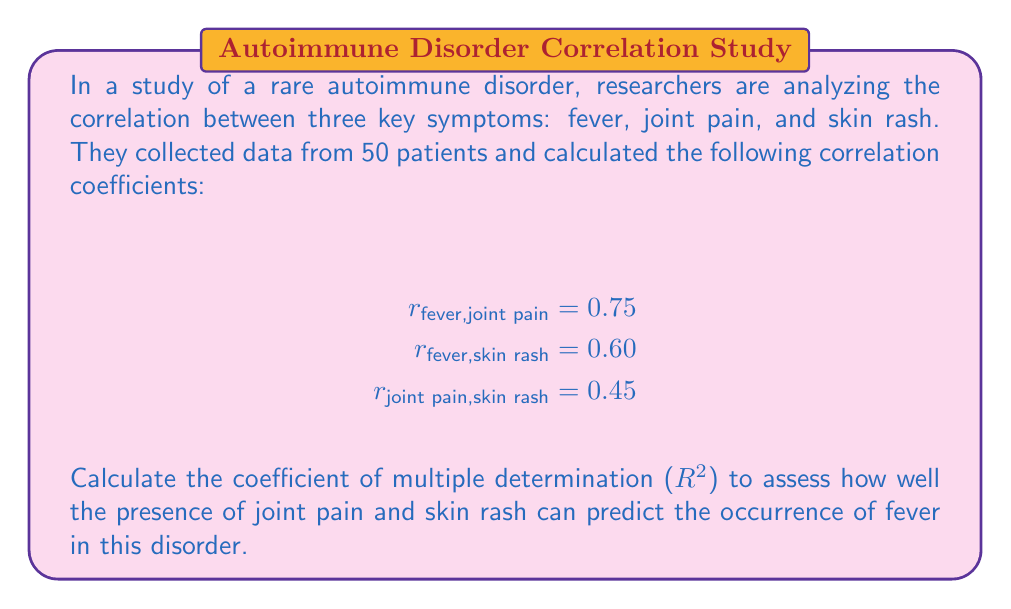Show me your answer to this math problem. To solve this problem, we'll use the formula for the coefficient of multiple determination ($R^2$) in a three-variable system:

$$R^2 = \frac{r_{12}^2 + r_{13}^2 - 2r_{12}r_{13}r_{23}}{1 - r_{23}^2}$$

Where:
1 represents fever
2 represents joint pain
3 represents skin rash

Step 1: Identify the correlation coefficients:
$r_{12} = r_{fever,joint pain} = 0.75$
$r_{13} = r_{fever,skin rash} = 0.60$
$r_{23} = r_{joint pain,skin rash} = 0.45$

Step 2: Substitute these values into the formula:

$$R^2 = \frac{(0.75)^2 + (0.60)^2 - 2(0.75)(0.60)(0.45)}{1 - (0.45)^2}$$

Step 3: Calculate the numerator:
$(0.75)^2 = 0.5625$
$(0.60)^2 = 0.3600$
$2(0.75)(0.60)(0.45) = 0.4050$

$0.5625 + 0.3600 - 0.4050 = 0.5175$

Step 4: Calculate the denominator:
$1 - (0.45)^2 = 1 - 0.2025 = 0.7975$

Step 5: Divide the numerator by the denominator:

$$R^2 = \frac{0.5175}{0.7975} = 0.6489$$

Step 6: Convert to a percentage:
$0.6489 * 100 = 64.89\%$

Therefore, the coefficient of multiple determination ($R^2$) is approximately 0.6489 or 64.89%.
Answer: $R^2 \approx 0.6489$ or $64.89\%$ 